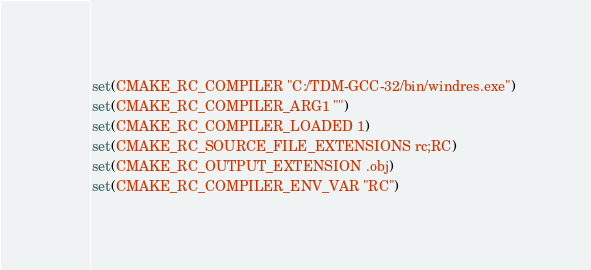<code> <loc_0><loc_0><loc_500><loc_500><_CMake_>set(CMAKE_RC_COMPILER "C:/TDM-GCC-32/bin/windres.exe")
set(CMAKE_RC_COMPILER_ARG1 "")
set(CMAKE_RC_COMPILER_LOADED 1)
set(CMAKE_RC_SOURCE_FILE_EXTENSIONS rc;RC)
set(CMAKE_RC_OUTPUT_EXTENSION .obj)
set(CMAKE_RC_COMPILER_ENV_VAR "RC")
</code> 